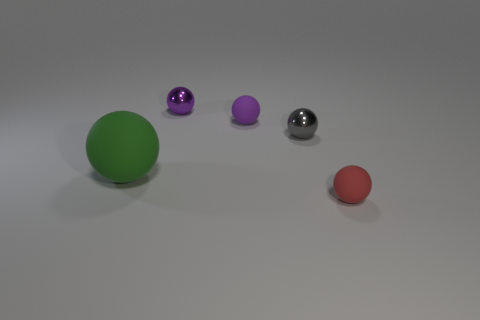How many small blue shiny balls are there?
Your answer should be very brief. 0. What number of green objects are large objects or big shiny cubes?
Your answer should be very brief. 1. How many other things are there of the same shape as the large green matte object?
Keep it short and to the point. 4. There is a small rubber ball that is behind the large matte ball; does it have the same color as the small shiny ball behind the tiny gray shiny object?
Your answer should be very brief. Yes. How many small objects are red spheres or gray shiny things?
Provide a short and direct response. 2. What is the size of the gray thing that is the same shape as the big green rubber thing?
Provide a succinct answer. Small. Are there any other things that are the same size as the green rubber ball?
Ensure brevity in your answer.  No. What is the material of the tiny purple ball that is behind the small matte thing behind the red matte ball?
Your response must be concise. Metal. What number of metal objects are green spheres or red spheres?
Give a very brief answer. 0. What color is the other shiny object that is the same shape as the gray metal thing?
Make the answer very short. Purple. 